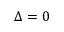<formula> <loc_0><loc_0><loc_500><loc_500>\Delta = 0</formula> 